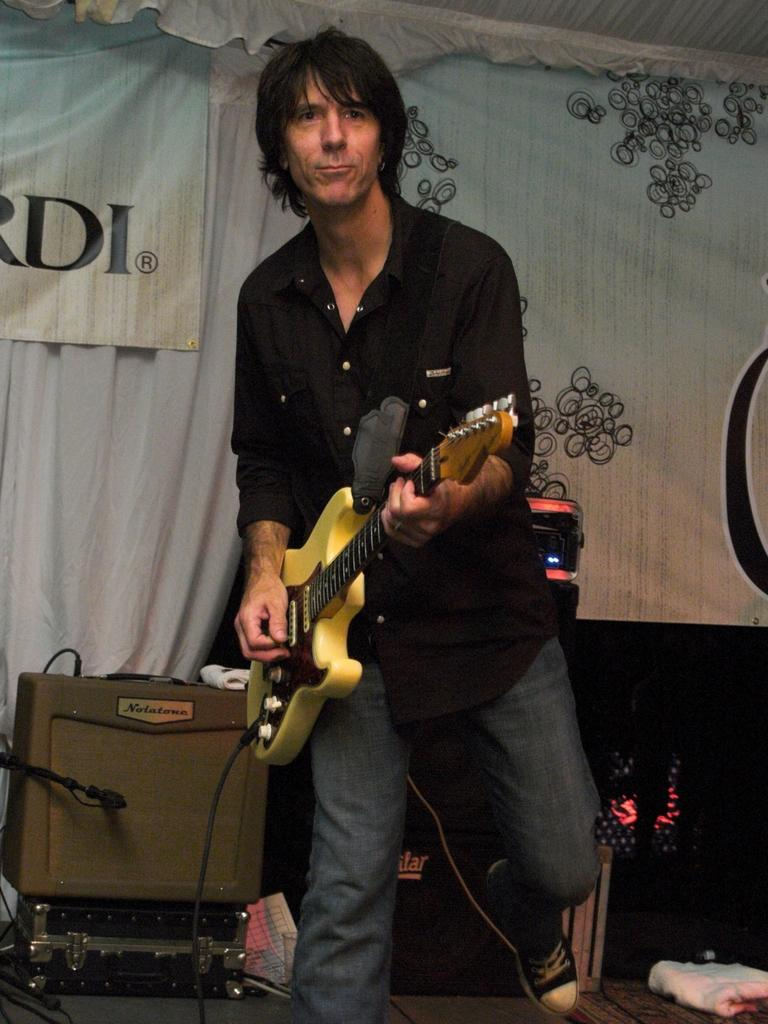What is the man in the image doing? The man is playing a guitar in the image. What is the man wearing? The man is wearing a black shirt in the image. What can be seen on the curtain in the image? There is a banner on the curtain in the image. What electronic items are visible in the image? There are devices visible in the image. What object can be seen in the image that might be used for storage? There is a box in the image. What type of metal is the man using to play the guitar in the image? The man is playing a guitar, which is typically made of wood or other materials, not metal. There is no metal instrument visible in the image. Can you tell me how much milk the man is holding in the image? There is no milk present in the image; the man is playing a guitar. 